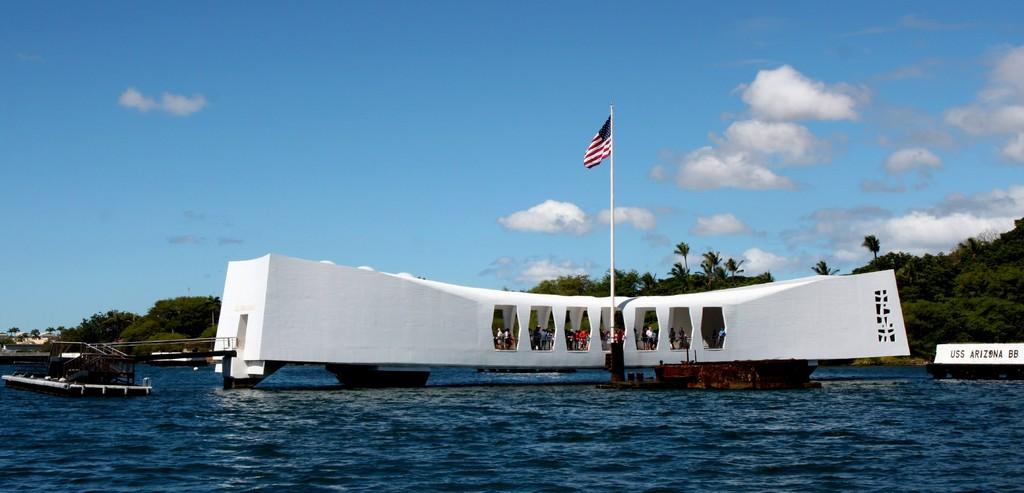Provide a one-sentence caption for the provided image. The tourists are visiting the Pearl Harbor USS Arizona. 